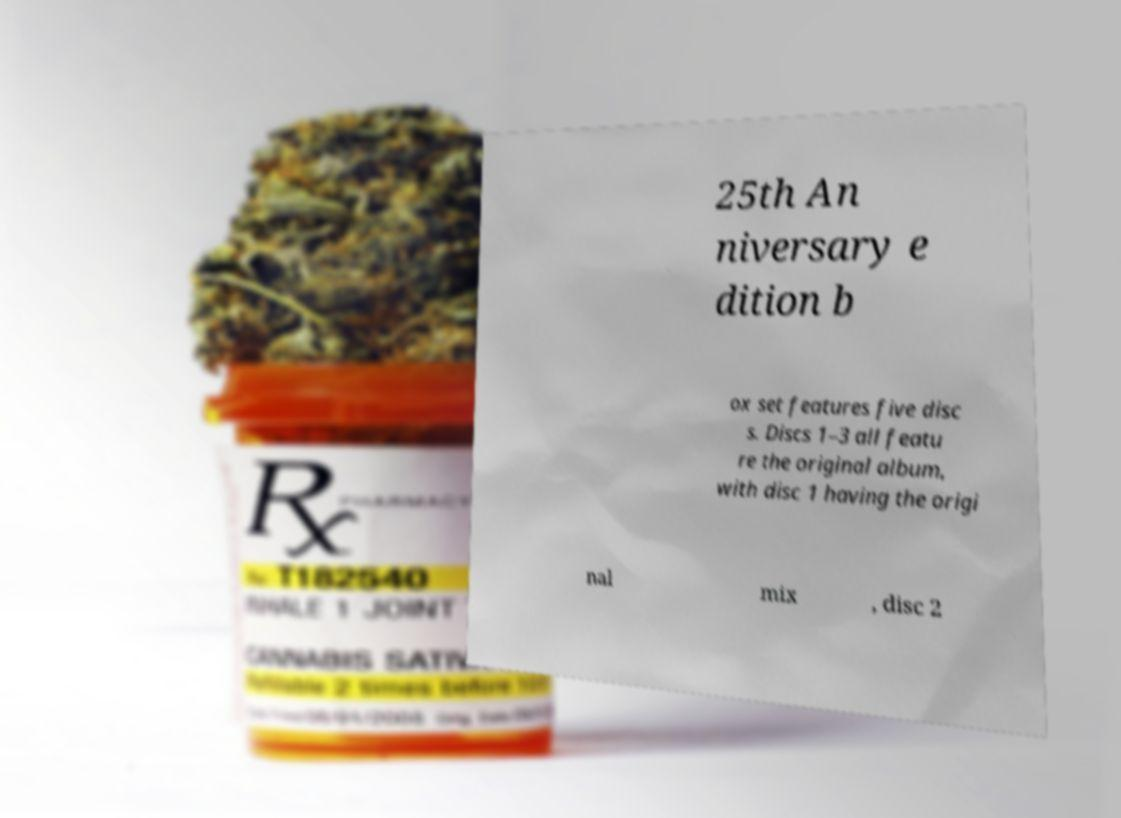Can you accurately transcribe the text from the provided image for me? 25th An niversary e dition b ox set features five disc s. Discs 1–3 all featu re the original album, with disc 1 having the origi nal mix , disc 2 